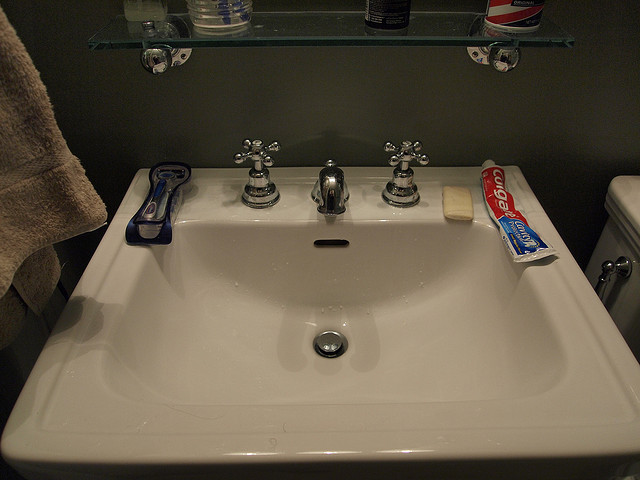Please transcribe the text in this image. Colgate 